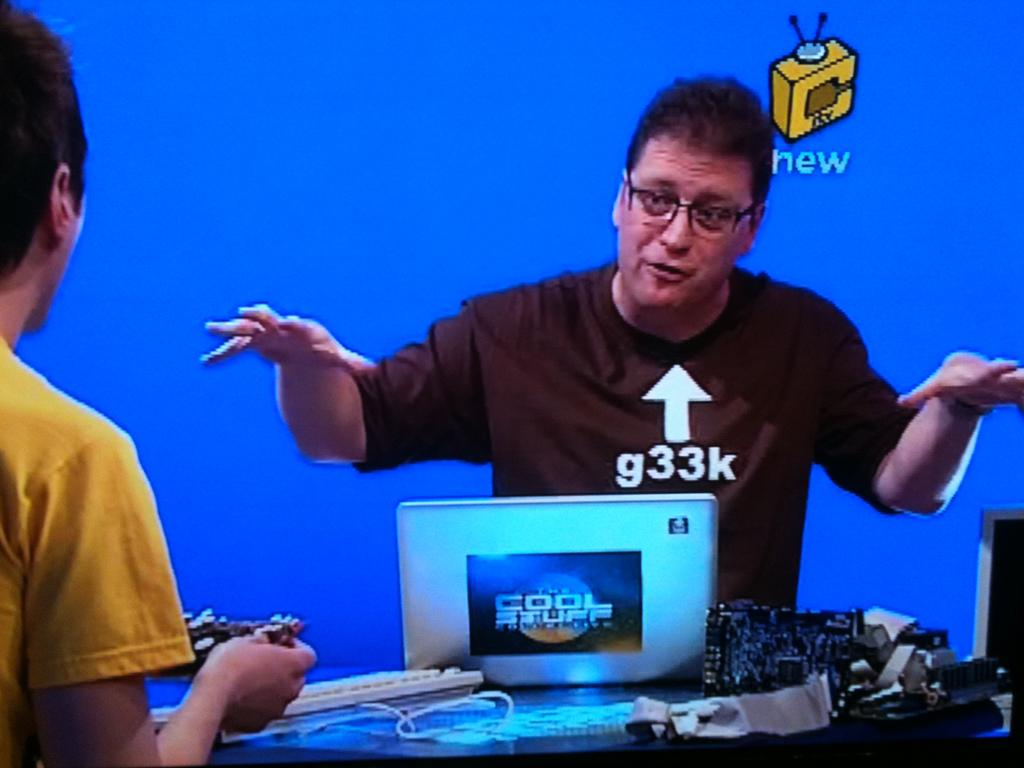<image>
Create a compact narrative representing the image presented. A man has an arrow pointing at him with g33k under it, 